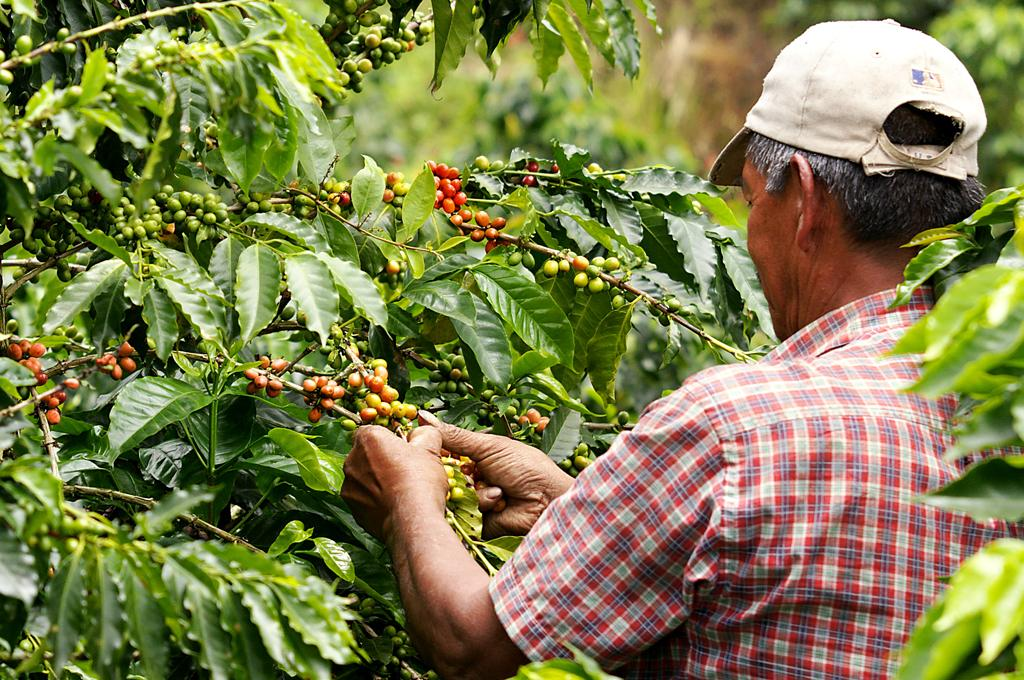What is present in the image? There is a man and a tree in the image. Can you describe the man's attire? The man is wearing clothes and a cap. What part of the tree is visible in the image? Tree leaves are visible in the image. How many goldfish are swimming in the tree leaves in the image? There are no goldfish present in the image; it features a man and a tree with visible leaves. What color is the crayon used to draw the value of the man's cap in the image? There is no crayon or drawing present in the image; it only shows a man wearing a cap. 